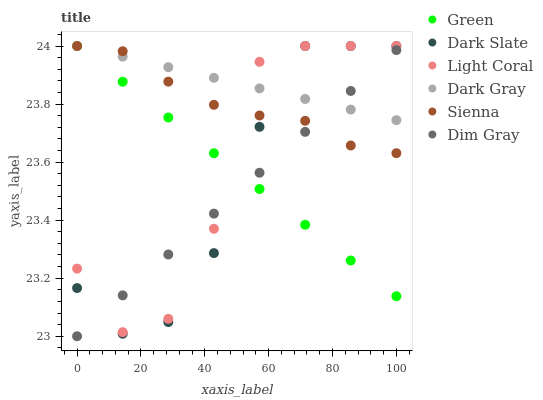Does Dim Gray have the minimum area under the curve?
Answer yes or no. Yes. Does Dark Gray have the maximum area under the curve?
Answer yes or no. Yes. Does Light Coral have the minimum area under the curve?
Answer yes or no. No. Does Light Coral have the maximum area under the curve?
Answer yes or no. No. Is Dim Gray the smoothest?
Answer yes or no. Yes. Is Light Coral the roughest?
Answer yes or no. Yes. Is Light Coral the smoothest?
Answer yes or no. No. Is Dim Gray the roughest?
Answer yes or no. No. Does Dim Gray have the lowest value?
Answer yes or no. Yes. Does Light Coral have the lowest value?
Answer yes or no. No. Does Sienna have the highest value?
Answer yes or no. Yes. Does Dim Gray have the highest value?
Answer yes or no. No. Does Light Coral intersect Dark Gray?
Answer yes or no. Yes. Is Light Coral less than Dark Gray?
Answer yes or no. No. Is Light Coral greater than Dark Gray?
Answer yes or no. No. 